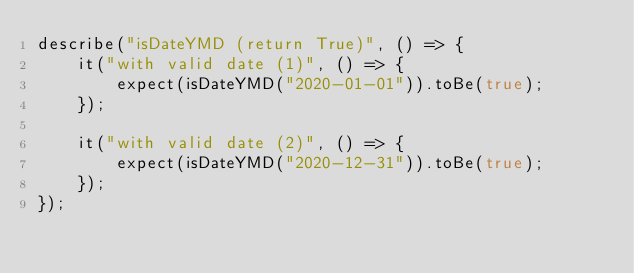Convert code to text. <code><loc_0><loc_0><loc_500><loc_500><_TypeScript_>describe("isDateYMD (return True)", () => {
	it("with valid date (1)", () => {
		expect(isDateYMD("2020-01-01")).toBe(true);
	});

	it("with valid date (2)", () => {
		expect(isDateYMD("2020-12-31")).toBe(true);
	});
});
</code> 